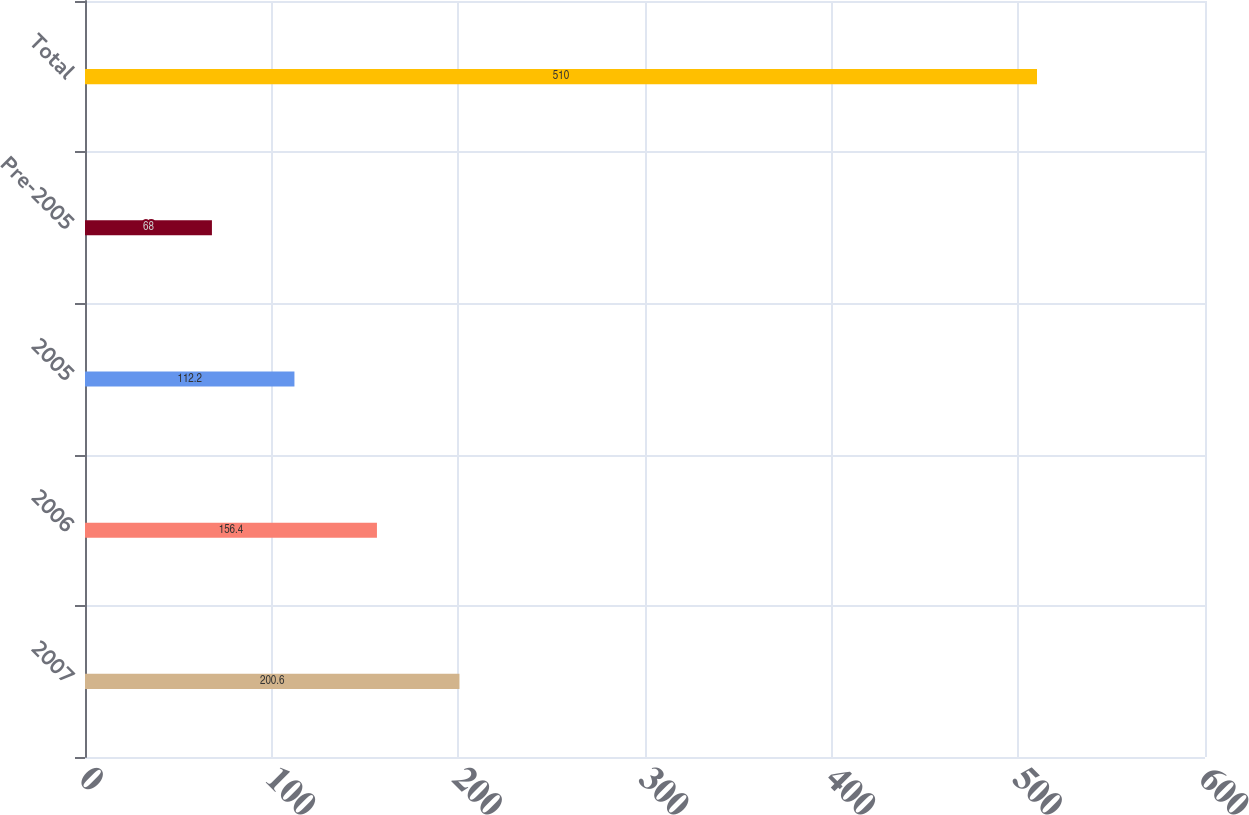<chart> <loc_0><loc_0><loc_500><loc_500><bar_chart><fcel>2007<fcel>2006<fcel>2005<fcel>Pre-2005<fcel>Total<nl><fcel>200.6<fcel>156.4<fcel>112.2<fcel>68<fcel>510<nl></chart> 